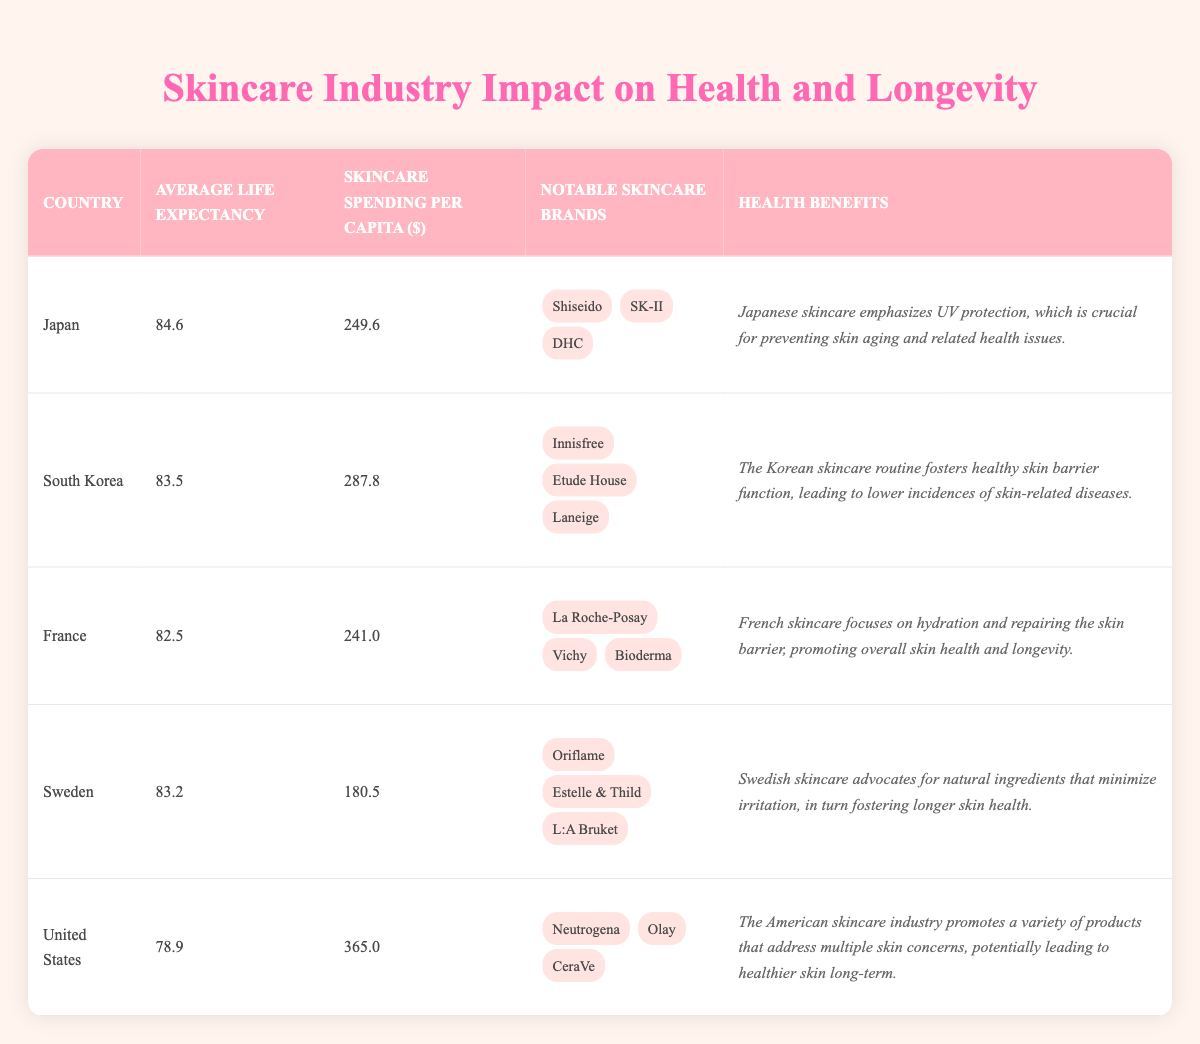What is the average life expectancy of Japan? In the table, Japan's average life expectancy is explicitly listed as 84.6 years.
Answer: 84.6 Which country has the highest skincare spending per capita? The table shows that the United States has the highest skincare spending per capita at 365.0 dollars.
Answer: United States What are the notable skincare brands in South Korea? South Korea's notable skincare brands are listed as Innisfree, Etude House, and Laneige in the table.
Answer: Innisfree, Etude House, Laneige What is the difference in average life expectancy between Japan and France? To find the difference, subtract France's average life expectancy (82.5) from Japan's (84.6): 84.6 - 82.5 = 2.1 years.
Answer: 2.1 years Is Swedish skincare known for using natural ingredients? The table states that Swedish skincare advocates for natural ingredients, indicating this is true.
Answer: Yes If we consider the average life expectancy based on the countries listed, which country's life expectancy is closest to the average? First, we calculate the average of the listed life expectancies: (84.6 + 83.5 + 82.5 + 83.2 + 78.9) / 5 = 82.74 years. The country with life expectancy closest to this average is Sweden at 83.2 years.
Answer: Sweden Which country promotes a skincare routine that fosters healthy skin barrier function? The table specifies that South Korean skincare fosters healthy skin barrier function, thus the answer is South Korea.
Answer: South Korea What is the average skincare spending per capita for France and Sweden combined? To find this, sum France's skincare spending (241.0) and Sweden's (180.5), then divide by 2: (241.0 + 180.5) / 2 = 210.75 dollars, which is the average.
Answer: 210.75 dollars Does the United States have a higher average life expectancy than South Korea? The average life expectancy for the United States is 78.9, and for South Korea, it is 83.5; therefore, the United States does not have a higher life expectancy.
Answer: No 